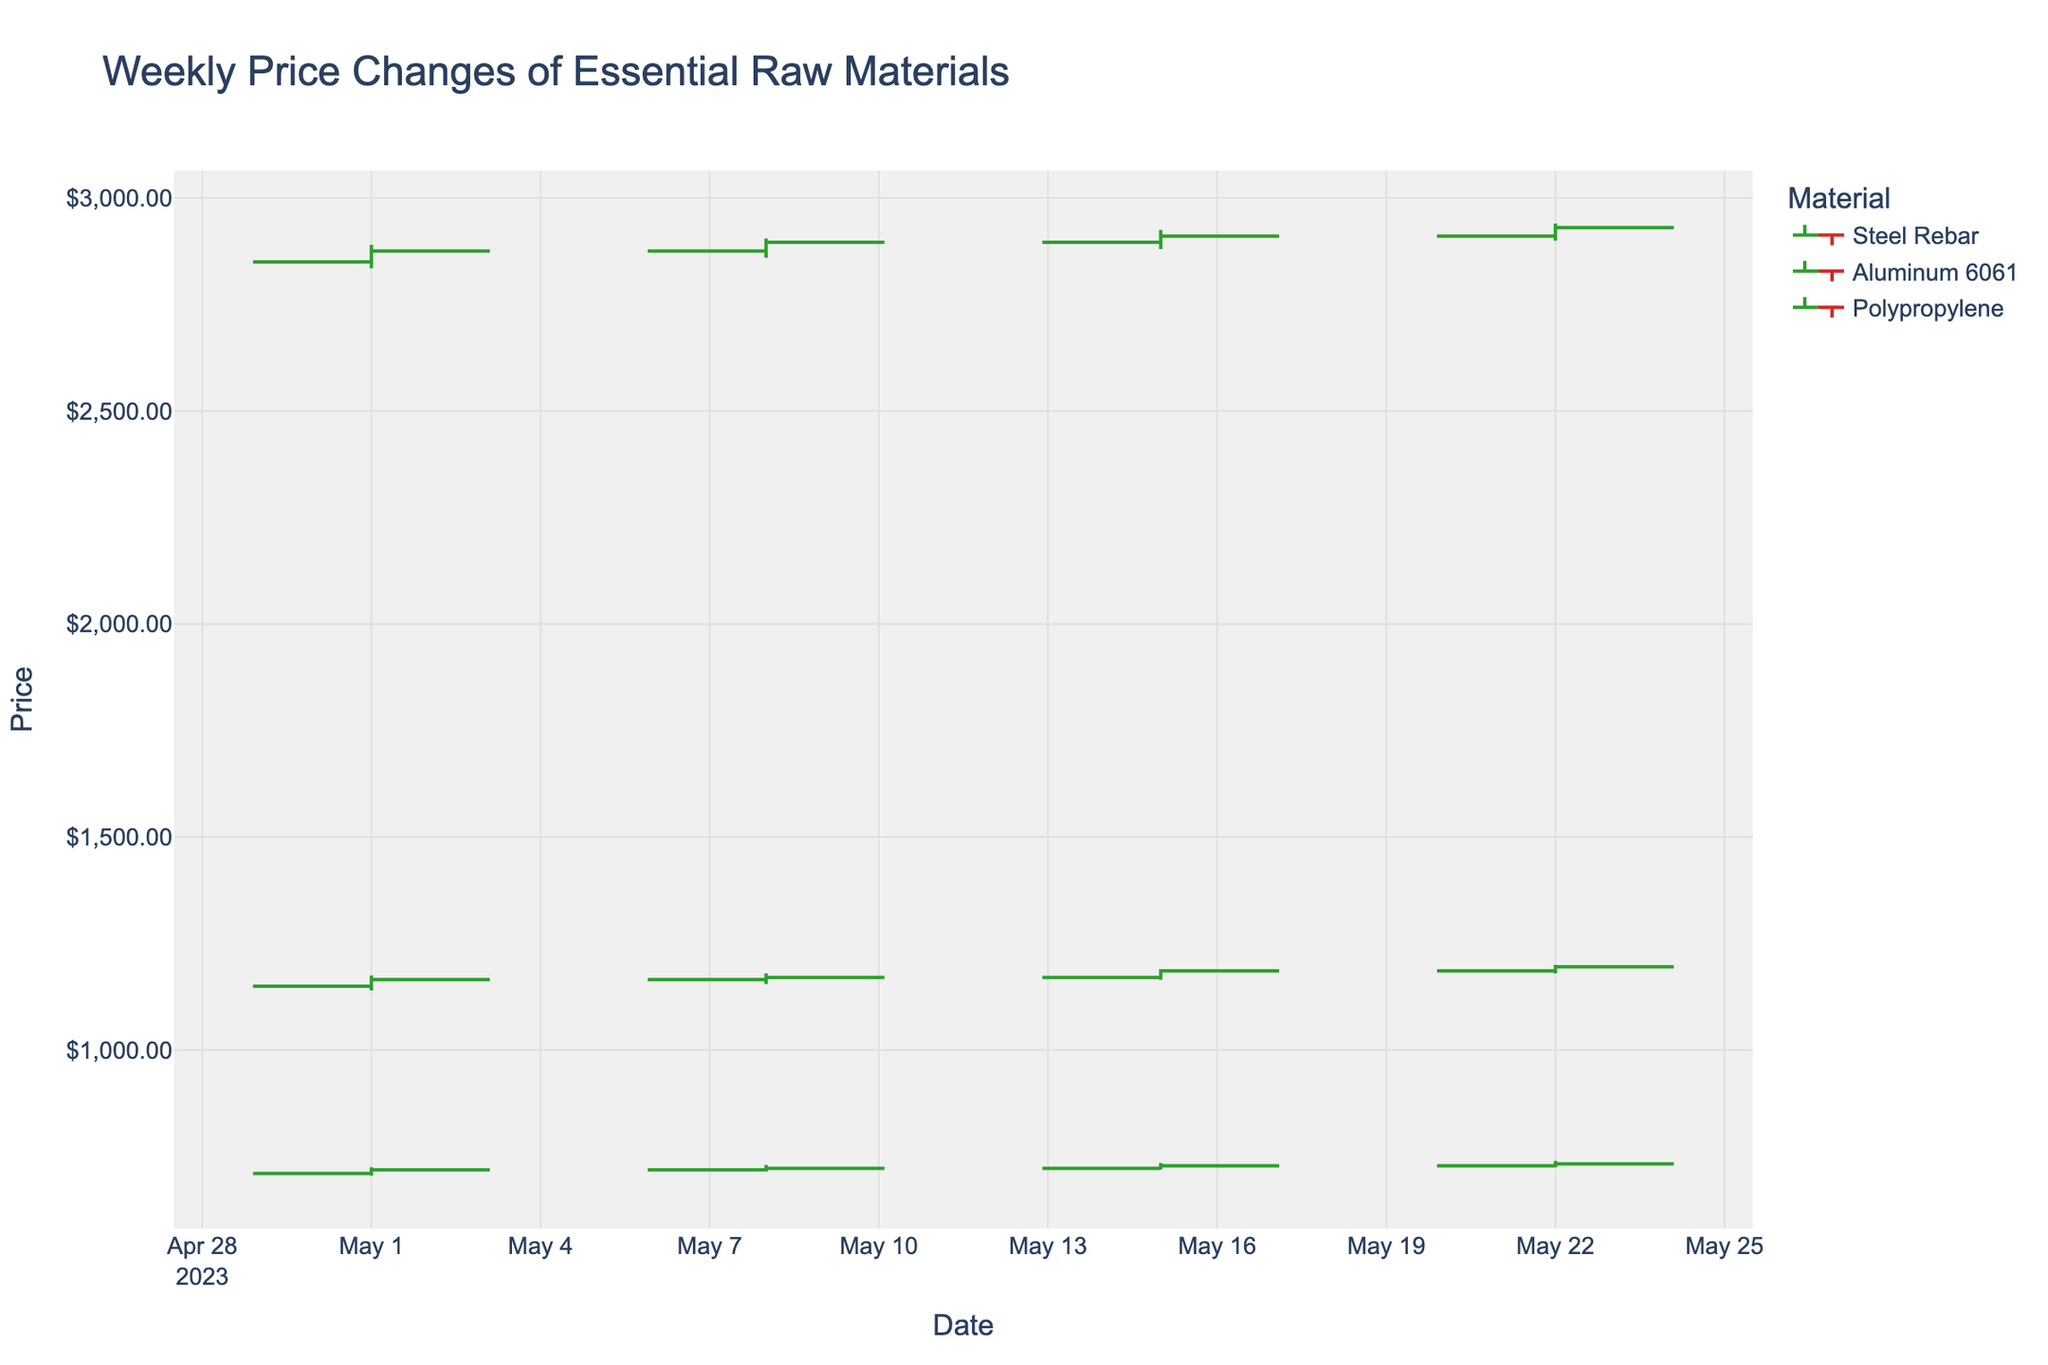What's the highest price recorded for Steel Rebar in May 2023? The highest price for Steel Rebar is marked by the "High" value on the OHLC chart. For Steel Rebar, the highest price recorded in May is $740.00, observed on May 22, 2023.
Answer: $740.00 Which material showed the greatest volatility (difference between high and low) in the week of May 15, 2023? To determine the greatest volatility, calculate the difference between the "High" and "Low" prices for each material in the week of May 15, 2023. For Steel Rebar, the difference is 735.00 - 720.00 = 15.00. For Aluminum 6061, the difference is 2925.00 - 2880.00 = 45.00. For Polypropylene, the difference is 1190.00 - 1165.00 = 25.00. Aluminum 6061 has the greatest volatility.
Answer: Aluminum 6061 Between Steel Rebar and Polypropylene, which material had a higher closing price on May 8, 2023? The closing price for Steel Rebar on May 8, 2023, is $722.25, and for Polypropylene, it's $1170.50. Comparing these values, Polypropylene had the higher closing price.
Answer: Polypropylene How many data points are plotted for each material in the figure? For each material (Steel Rebar, Aluminum 6061, and Polypropylene), there is one data point per week. Since there are four weeks of data, there are 4 data points plotted for each material.
Answer: 4 What is the overall trend in the closing price of Aluminum 6061 across the given period? To identify the trend, observe the closing prices for Aluminum 6061 on each date: May 1 ($2875.50), May 8 ($2895.75), May 15 ($2910.25), and May 22 ($2930.50). The prices show an increasing trend over the weeks.
Answer: Increasing Which material experienced the smallest weekly closing price increase on May 15, 2023, compared to the previous week? For each material, calculate the difference between the closing prices of May 8 and May 15, 2023. For Steel Rebar, the increase is 728.50 - 722.25 = 6.25. For Aluminum 6061, the increase is 2910.25 - 2895.75 = 14.50. For Polypropylene, the increase is 1185.75 - 1170.50 = 15.25. Steel Rebar experienced the smallest increase.
Answer: Steel Rebar What was the closing price of Polypropylene on May 22, 2023? Refer to the OHLC for Polypropylene on May 22, 2023, to find the closing price, which is $1195.25.
Answer: $1195.25 Did any material have a higher closing price than its opening price every week? Compare the closing price to the opening price for each material each week. For Steel Rebar: yes (all weeks). For Aluminum 6061: yes (all weeks). For Polypropylene: yes (all weeks). Each material had this pattern.
Answer: Yes Which material had the smallest range (high minus low) on May 1, 2023? Calculate the range for each material on May 1, 2023. For Steel Rebar, the range is 725.00 - 705.25 = 19.75. For Aluminum 6061, the range is 2890.00 - 2835.00 = 55.00. For Polypropylene, the range is 1175.00 - 1140.00 = 35.00. Steel Rebar had the smallest range.
Answer: Steel Rebar On which date did Steel Rebar have its highest closing price in May 2023? By comparing the closing prices of Steel Rebar: May 1 ($718.75), May 8 ($722.25), May 15 ($728.50), and May 22 ($732.75), the highest closing price is on May 22, 2023.
Answer: May 22, 2023 